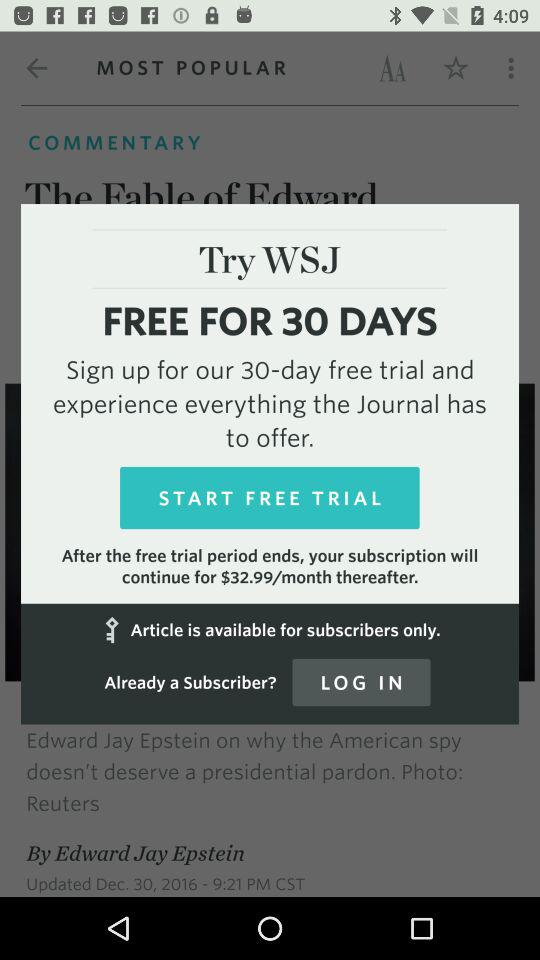How much is the subscription after the free trial period ends?
Answer the question using a single word or phrase. $32.99/month 